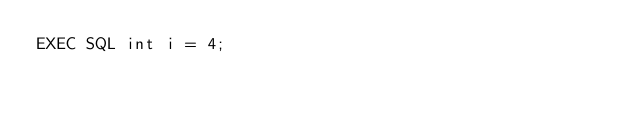Convert code to text. <code><loc_0><loc_0><loc_500><loc_500><_SQL_>EXEC SQL int i = 4;
</code> 